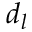Convert formula to latex. <formula><loc_0><loc_0><loc_500><loc_500>d _ { l }</formula> 